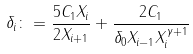<formula> <loc_0><loc_0><loc_500><loc_500>\delta _ { i } \colon = \frac { 5 C _ { 1 } X _ { i } } { 2 X _ { i + 1 } } + \frac { 2 C _ { 1 } } { \delta _ { 0 } X _ { i - 1 } X _ { i } ^ { \gamma + 1 } }</formula> 